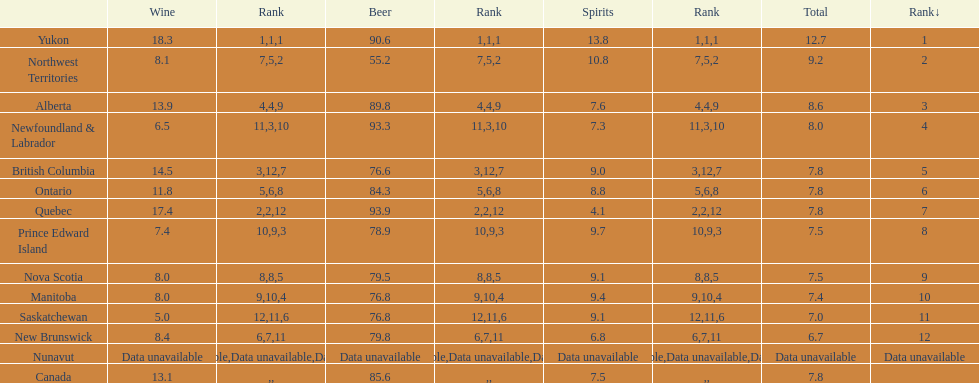Quebuec had a beer consumption of 93.9, what was their spirit consumption? 4.1. Would you be able to parse every entry in this table? {'header': ['', 'Wine', 'Rank', 'Beer', 'Rank', 'Spirits', 'Rank', 'Total', 'Rank↓'], 'rows': [['Yukon', '18.3', '1', '90.6', '1', '13.8', '1', '12.7', '1'], ['Northwest Territories', '8.1', '7', '55.2', '5', '10.8', '2', '9.2', '2'], ['Alberta', '13.9', '4', '89.8', '4', '7.6', '9', '8.6', '3'], ['Newfoundland & Labrador', '6.5', '11', '93.3', '3', '7.3', '10', '8.0', '4'], ['British Columbia', '14.5', '3', '76.6', '12', '9.0', '7', '7.8', '5'], ['Ontario', '11.8', '5', '84.3', '6', '8.8', '8', '7.8', '6'], ['Quebec', '17.4', '2', '93.9', '2', '4.1', '12', '7.8', '7'], ['Prince Edward Island', '7.4', '10', '78.9', '9', '9.7', '3', '7.5', '8'], ['Nova Scotia', '8.0', '8', '79.5', '8', '9.1', '5', '7.5', '9'], ['Manitoba', '8.0', '9', '76.8', '10', '9.4', '4', '7.4', '10'], ['Saskatchewan', '5.0', '12', '76.8', '11', '9.1', '6', '7.0', '11'], ['New Brunswick', '8.4', '6', '79.8', '7', '6.8', '11', '6.7', '12'], ['Nunavut', 'Data unavailable', 'Data unavailable', 'Data unavailable', 'Data unavailable', 'Data unavailable', 'Data unavailable', 'Data unavailable', 'Data unavailable'], ['Canada', '13.1', '', '85.6', '', '7.5', '', '7.8', '']]} 